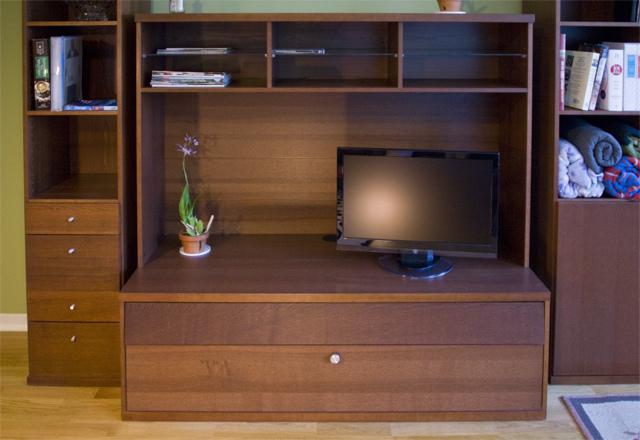How many drawers are shown?
Give a very brief answer. 5. Is the tv on?
Answer briefly. No. What room is this?
Write a very short answer. Living room. What kind of flower is in the pot?
Answer briefly. Orchid. Is this a new t.v.?
Write a very short answer. Yes. How many plants are in the picture?
Be succinct. 1. What is on the bottom shelf?
Give a very brief answer. Tv. 